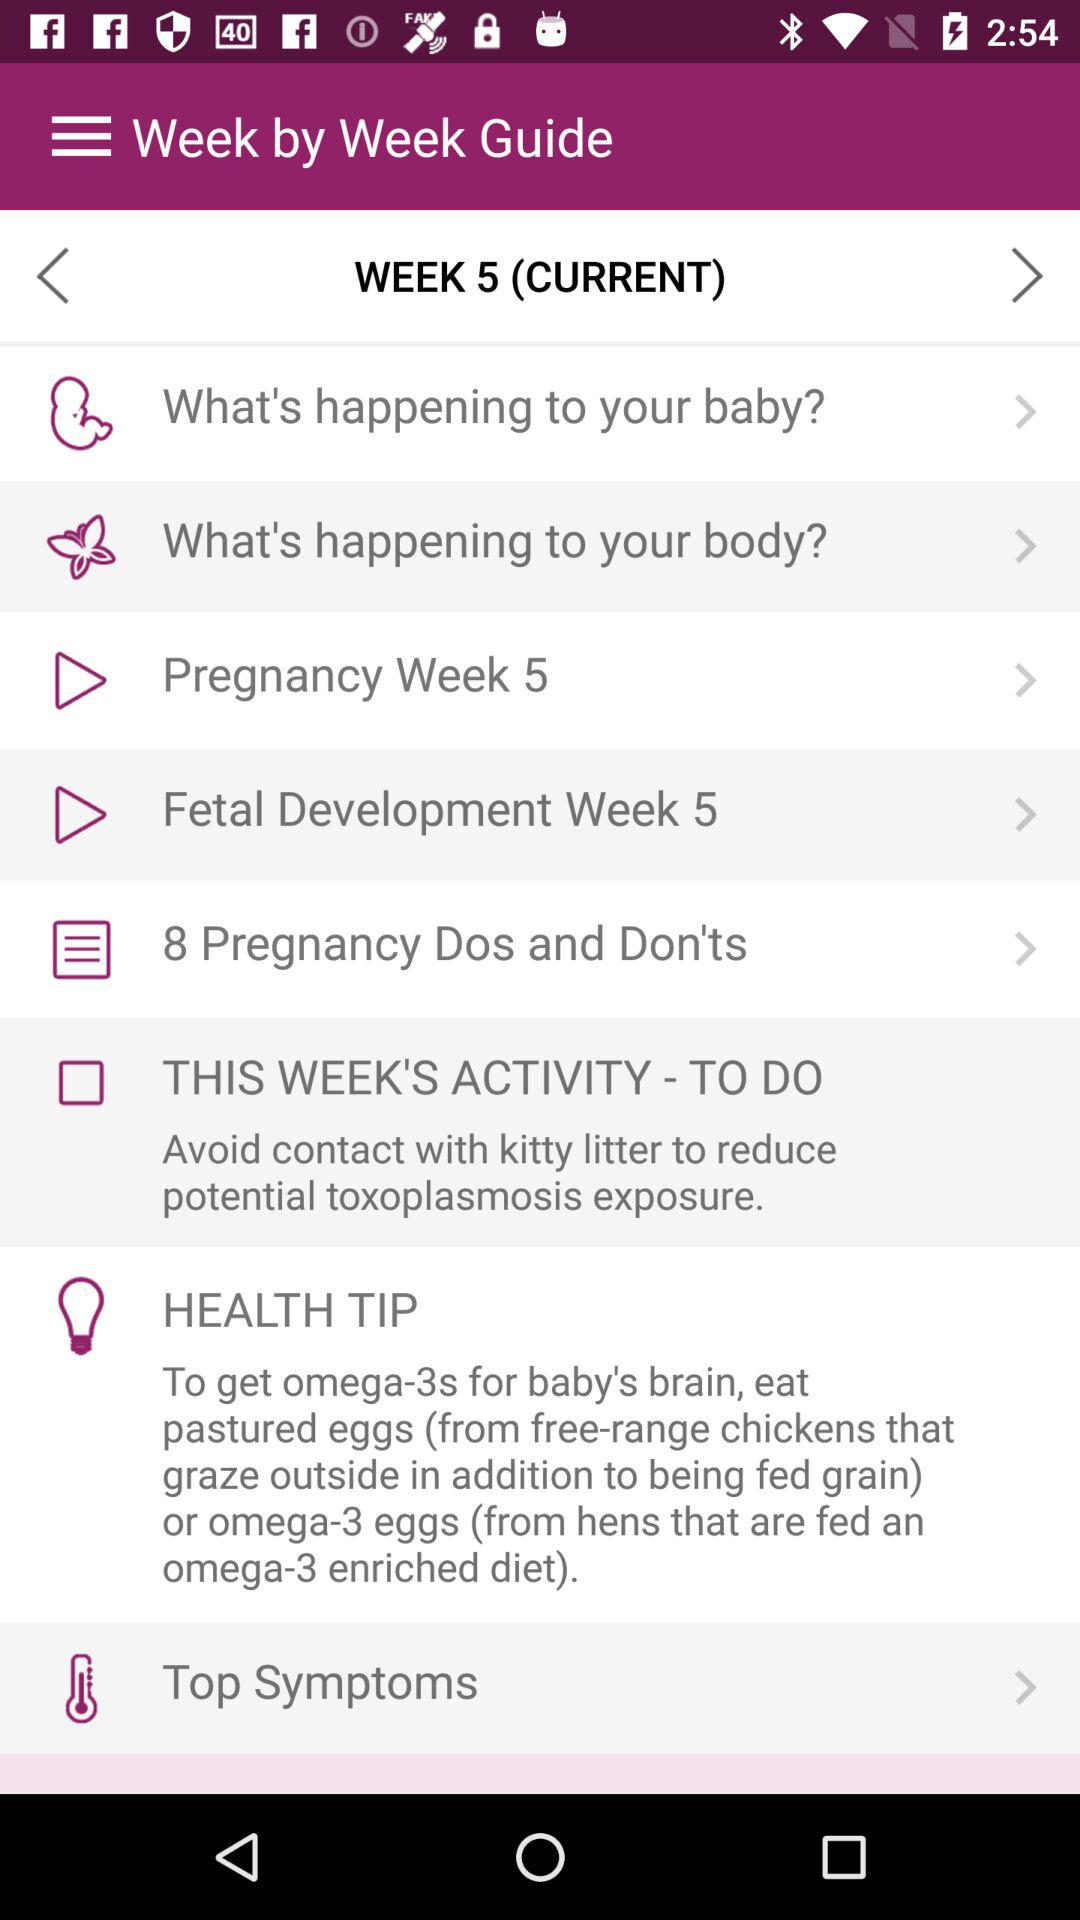How much should the fetus weigh at 5 weeks?
When the provided information is insufficient, respond with <no answer>. <no answer> 